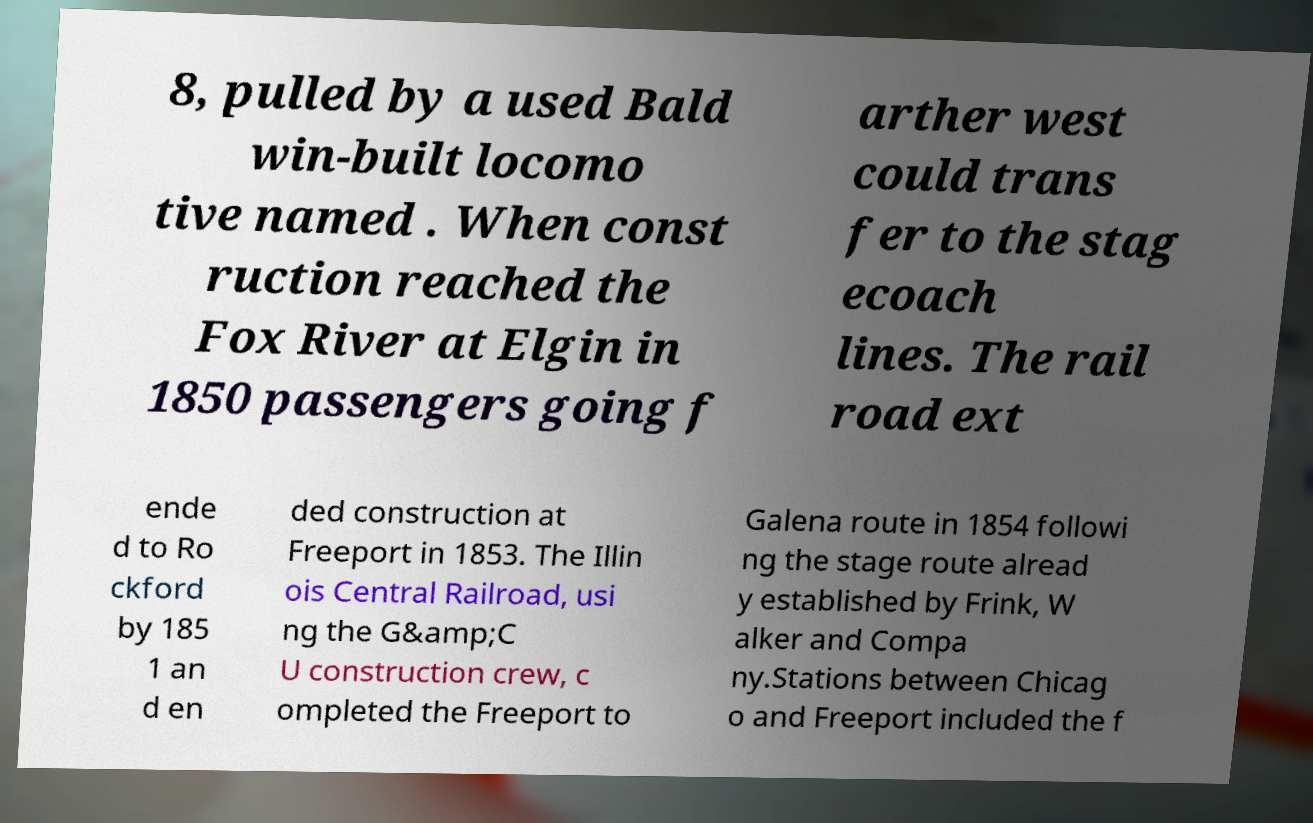Can you accurately transcribe the text from the provided image for me? 8, pulled by a used Bald win-built locomo tive named . When const ruction reached the Fox River at Elgin in 1850 passengers going f arther west could trans fer to the stag ecoach lines. The rail road ext ende d to Ro ckford by 185 1 an d en ded construction at Freeport in 1853. The Illin ois Central Railroad, usi ng the G&amp;C U construction crew, c ompleted the Freeport to Galena route in 1854 followi ng the stage route alread y established by Frink, W alker and Compa ny.Stations between Chicag o and Freeport included the f 